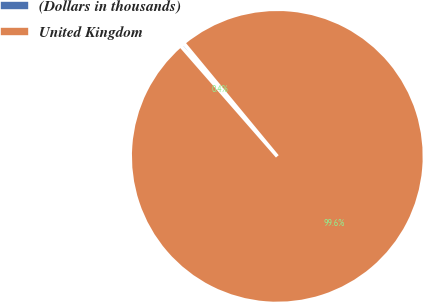<chart> <loc_0><loc_0><loc_500><loc_500><pie_chart><fcel>(Dollars in thousands)<fcel>United Kingdom<nl><fcel>0.44%<fcel>99.56%<nl></chart> 